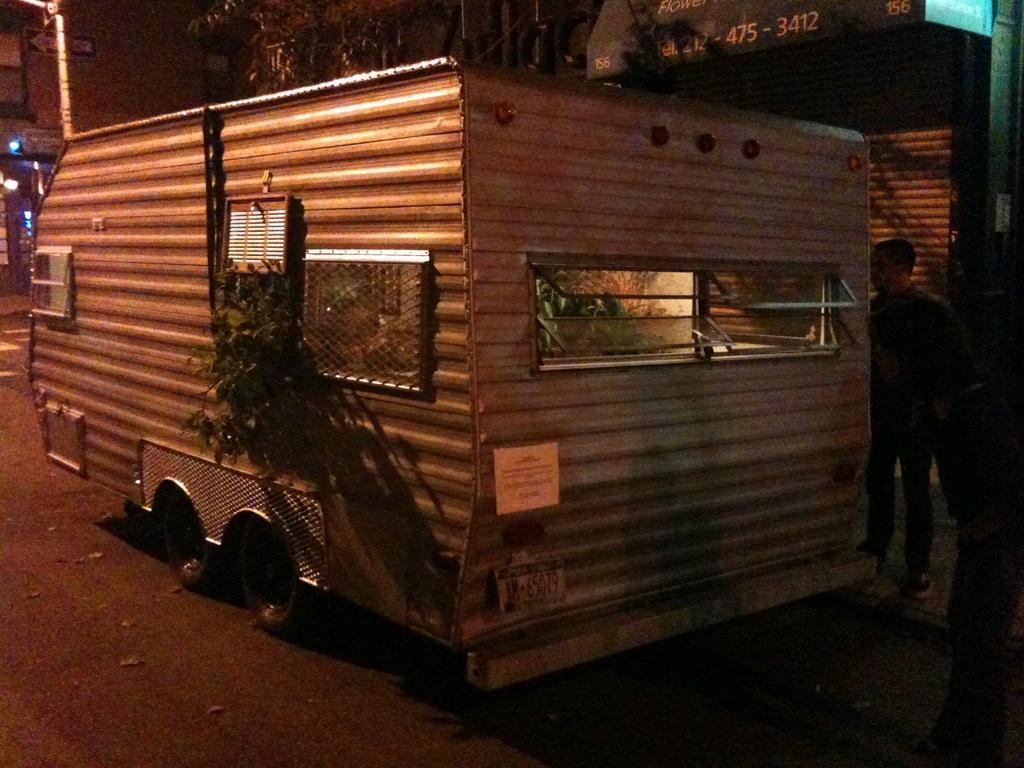Can you describe this image briefly? In this image I can see a vehicle and I can see a window and plant on the vehicle and in front of the vehicle I can see a person on the left side, at the top I can see building and tree and light. 